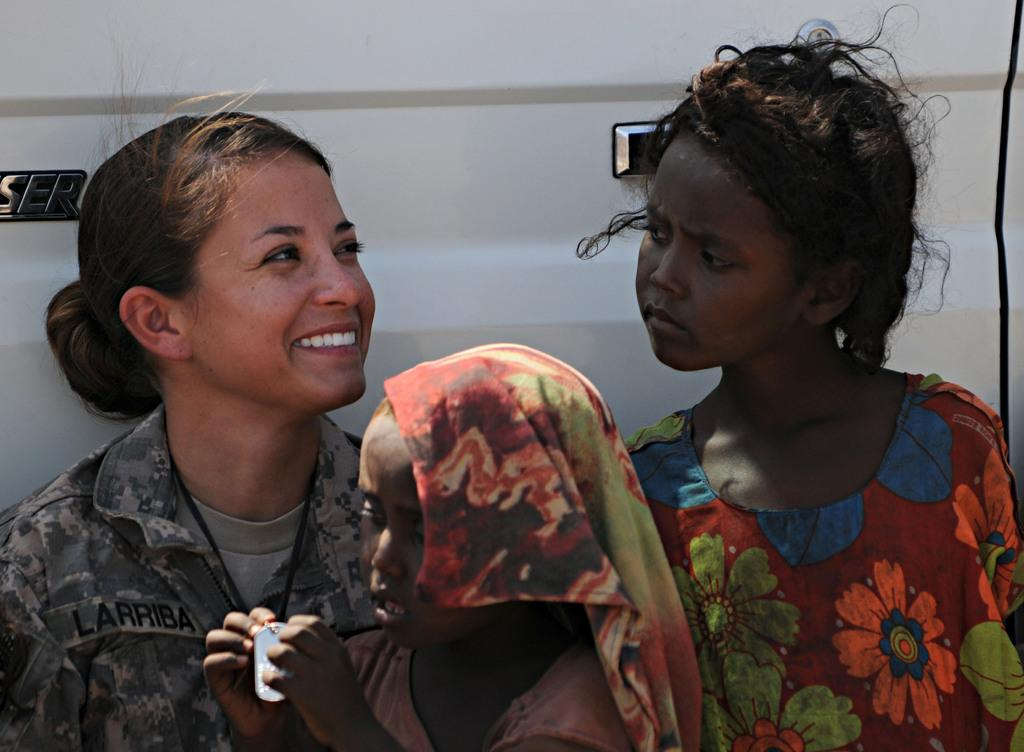Who is present in the image? There is a woman and two girls in the image. What can be seen in the background of the image? There is a white car, a door, and a logo in the background of the image. What type of curtain is hanging in the woman's throat in the image? There is no curtain present in the image, and the woman's throat is not mentioned. 